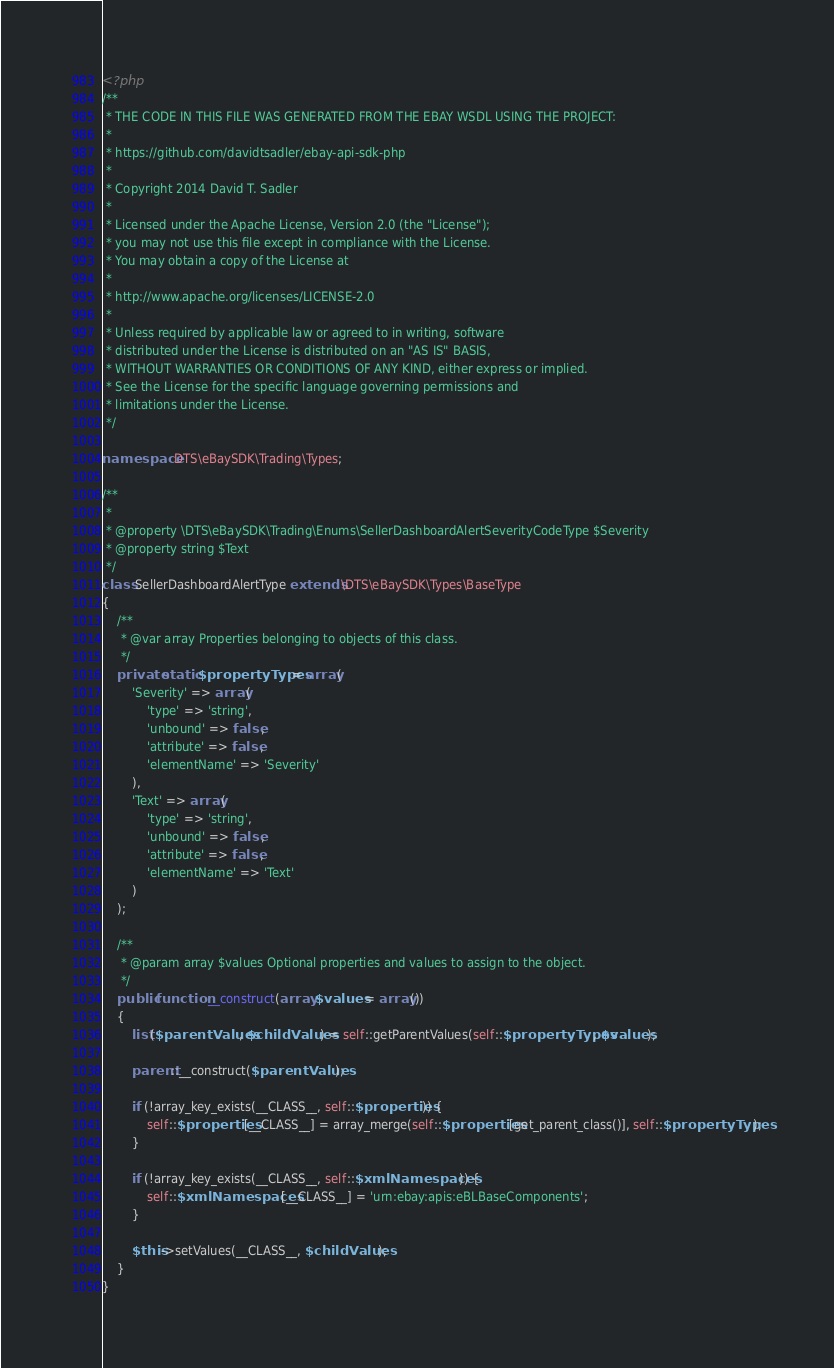<code> <loc_0><loc_0><loc_500><loc_500><_PHP_><?php
/**
 * THE CODE IN THIS FILE WAS GENERATED FROM THE EBAY WSDL USING THE PROJECT:
 *
 * https://github.com/davidtsadler/ebay-api-sdk-php
 *
 * Copyright 2014 David T. Sadler
 *
 * Licensed under the Apache License, Version 2.0 (the "License");
 * you may not use this file except in compliance with the License.
 * You may obtain a copy of the License at
 *
 * http://www.apache.org/licenses/LICENSE-2.0
 *
 * Unless required by applicable law or agreed to in writing, software
 * distributed under the License is distributed on an "AS IS" BASIS,
 * WITHOUT WARRANTIES OR CONDITIONS OF ANY KIND, either express or implied.
 * See the License for the specific language governing permissions and
 * limitations under the License.
 */

namespace DTS\eBaySDK\Trading\Types;

/**
 *
 * @property \DTS\eBaySDK\Trading\Enums\SellerDashboardAlertSeverityCodeType $Severity
 * @property string $Text
 */
class SellerDashboardAlertType extends \DTS\eBaySDK\Types\BaseType
{
    /**
     * @var array Properties belonging to objects of this class.
     */
    private static $propertyTypes = array(
        'Severity' => array(
            'type' => 'string',
            'unbound' => false,
            'attribute' => false,
            'elementName' => 'Severity'
        ),
        'Text' => array(
            'type' => 'string',
            'unbound' => false,
            'attribute' => false,
            'elementName' => 'Text'
        )
    );

    /**
     * @param array $values Optional properties and values to assign to the object.
     */
    public function __construct(array $values = array())
    {
        list($parentValues, $childValues) = self::getParentValues(self::$propertyTypes, $values);

        parent::__construct($parentValues);

        if (!array_key_exists(__CLASS__, self::$properties)) {
            self::$properties[__CLASS__] = array_merge(self::$properties[get_parent_class()], self::$propertyTypes);
        }

        if (!array_key_exists(__CLASS__, self::$xmlNamespaces)) {
            self::$xmlNamespaces[__CLASS__] = 'urn:ebay:apis:eBLBaseComponents';
        }

        $this->setValues(__CLASS__, $childValues);
    }
}
</code> 